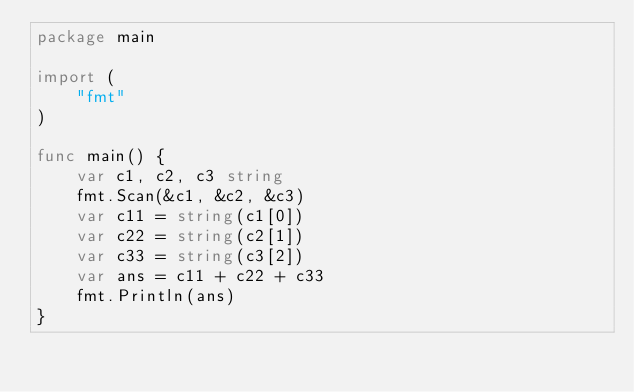Convert code to text. <code><loc_0><loc_0><loc_500><loc_500><_Go_>package main

import (
    "fmt"
)

func main() {
    var c1, c2, c3 string
    fmt.Scan(&c1, &c2, &c3)
    var c11 = string(c1[0])
    var c22 = string(c2[1])
    var c33 = string(c3[2])
    var ans = c11 + c22 + c33
    fmt.Println(ans)
}</code> 